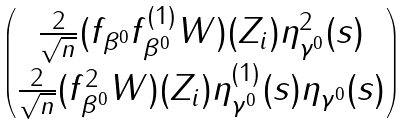Convert formula to latex. <formula><loc_0><loc_0><loc_500><loc_500>\begin{pmatrix} \frac { 2 } { \sqrt { n } } ( f _ { \beta ^ { 0 } } f _ { \beta ^ { 0 } } ^ { ( 1 ) } W ) ( Z _ { i } ) \eta ^ { 2 } _ { \gamma ^ { 0 } } ( s ) \\ \frac { 2 } { \sqrt { n } } ( f _ { \beta ^ { 0 } } ^ { 2 } W ) ( Z _ { i } ) \eta _ { \gamma ^ { 0 } } ^ { ( 1 ) } ( s ) \eta _ { \gamma ^ { 0 } } ( s ) \end{pmatrix}</formula> 